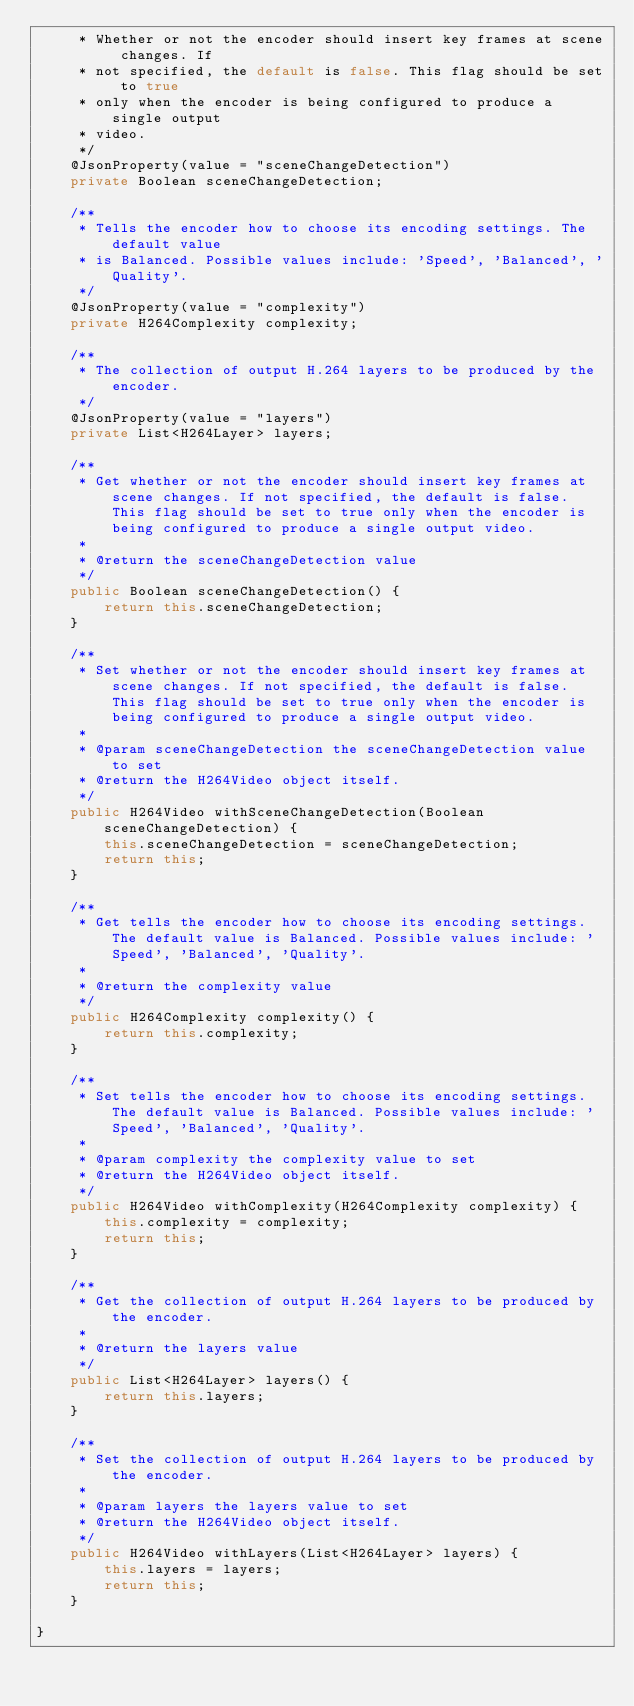<code> <loc_0><loc_0><loc_500><loc_500><_Java_>     * Whether or not the encoder should insert key frames at scene changes. If
     * not specified, the default is false. This flag should be set to true
     * only when the encoder is being configured to produce a single output
     * video.
     */
    @JsonProperty(value = "sceneChangeDetection")
    private Boolean sceneChangeDetection;

    /**
     * Tells the encoder how to choose its encoding settings. The default value
     * is Balanced. Possible values include: 'Speed', 'Balanced', 'Quality'.
     */
    @JsonProperty(value = "complexity")
    private H264Complexity complexity;

    /**
     * The collection of output H.264 layers to be produced by the encoder.
     */
    @JsonProperty(value = "layers")
    private List<H264Layer> layers;

    /**
     * Get whether or not the encoder should insert key frames at scene changes. If not specified, the default is false. This flag should be set to true only when the encoder is being configured to produce a single output video.
     *
     * @return the sceneChangeDetection value
     */
    public Boolean sceneChangeDetection() {
        return this.sceneChangeDetection;
    }

    /**
     * Set whether or not the encoder should insert key frames at scene changes. If not specified, the default is false. This flag should be set to true only when the encoder is being configured to produce a single output video.
     *
     * @param sceneChangeDetection the sceneChangeDetection value to set
     * @return the H264Video object itself.
     */
    public H264Video withSceneChangeDetection(Boolean sceneChangeDetection) {
        this.sceneChangeDetection = sceneChangeDetection;
        return this;
    }

    /**
     * Get tells the encoder how to choose its encoding settings. The default value is Balanced. Possible values include: 'Speed', 'Balanced', 'Quality'.
     *
     * @return the complexity value
     */
    public H264Complexity complexity() {
        return this.complexity;
    }

    /**
     * Set tells the encoder how to choose its encoding settings. The default value is Balanced. Possible values include: 'Speed', 'Balanced', 'Quality'.
     *
     * @param complexity the complexity value to set
     * @return the H264Video object itself.
     */
    public H264Video withComplexity(H264Complexity complexity) {
        this.complexity = complexity;
        return this;
    }

    /**
     * Get the collection of output H.264 layers to be produced by the encoder.
     *
     * @return the layers value
     */
    public List<H264Layer> layers() {
        return this.layers;
    }

    /**
     * Set the collection of output H.264 layers to be produced by the encoder.
     *
     * @param layers the layers value to set
     * @return the H264Video object itself.
     */
    public H264Video withLayers(List<H264Layer> layers) {
        this.layers = layers;
        return this;
    }

}
</code> 